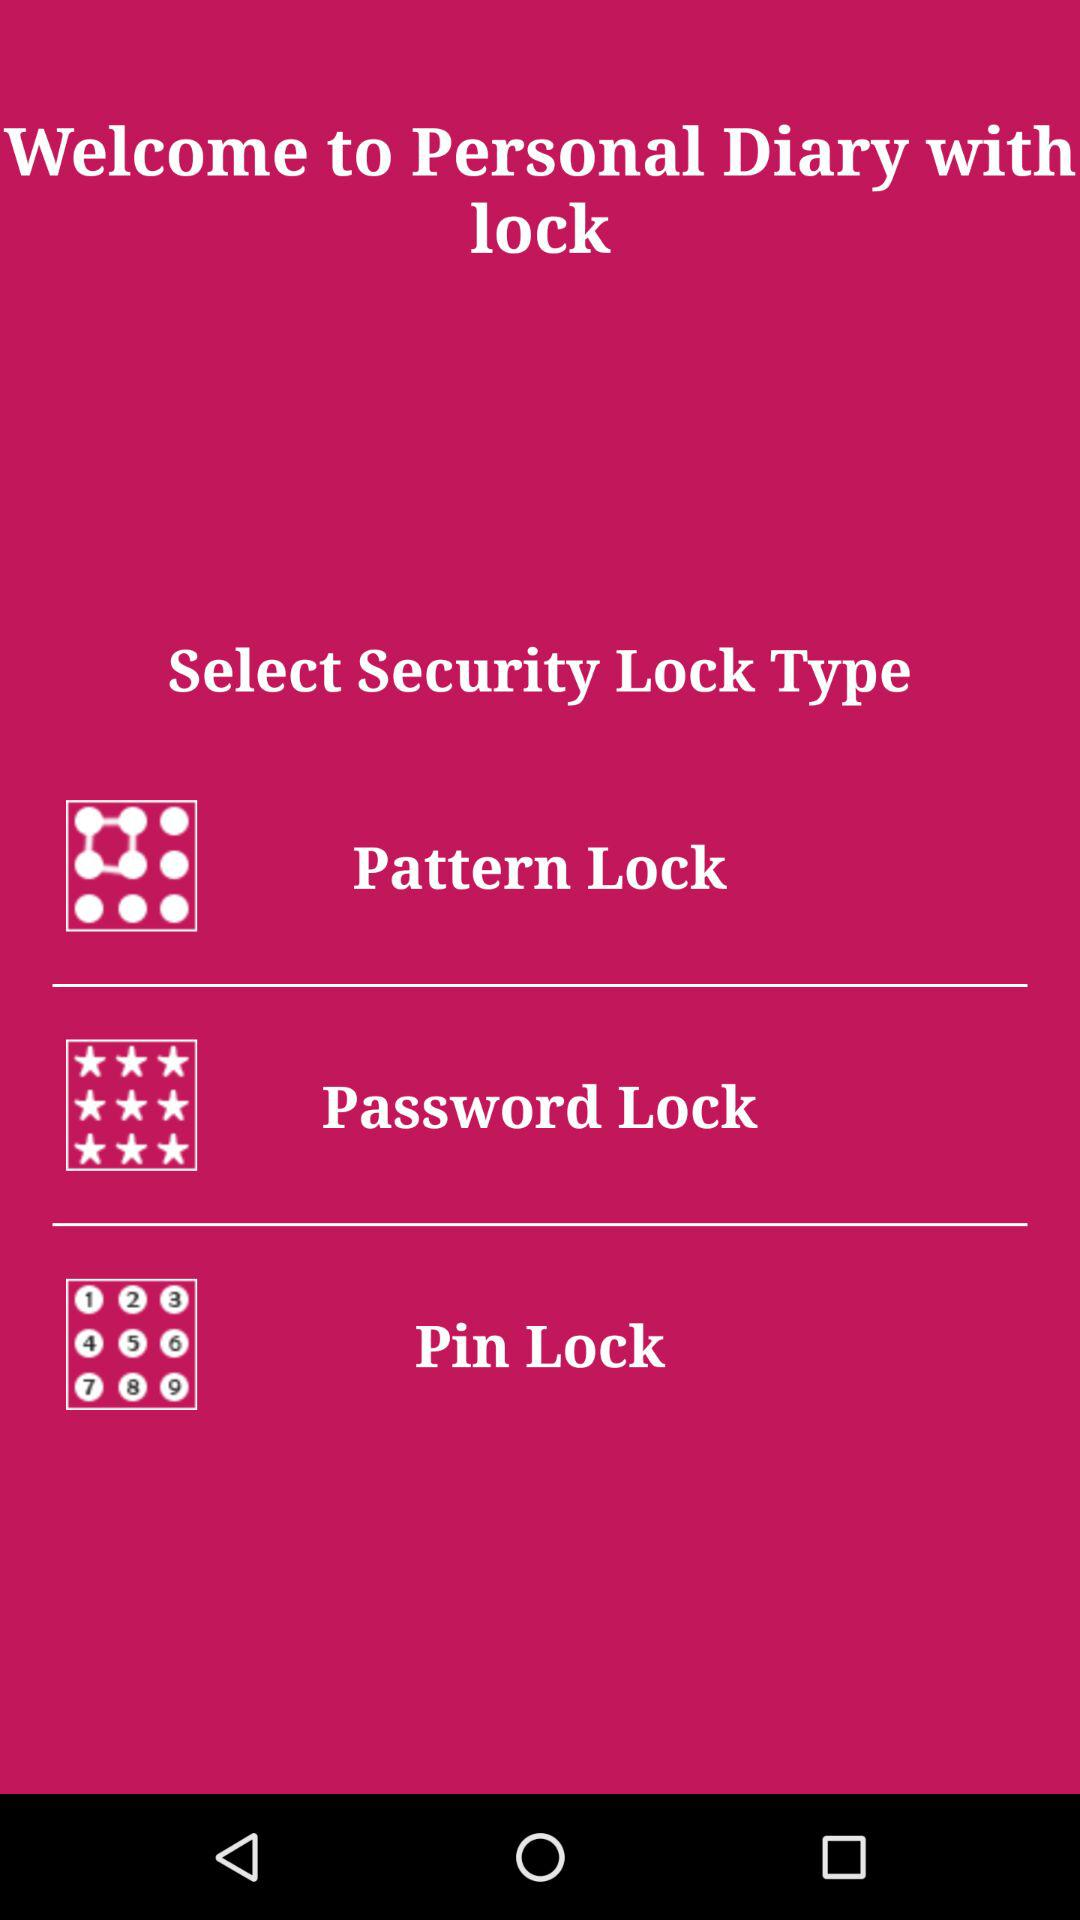What is the name of the application? The application name is "Personal Diary with lock". 